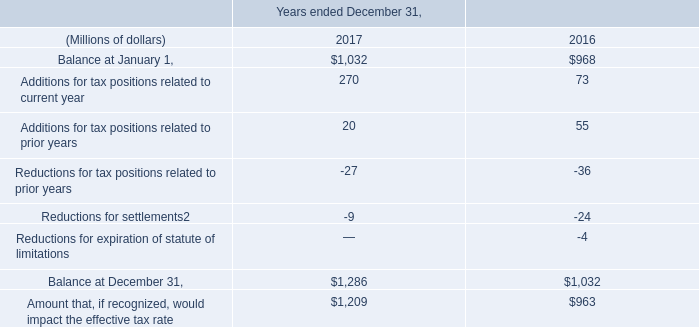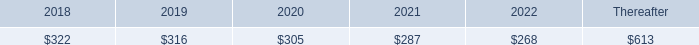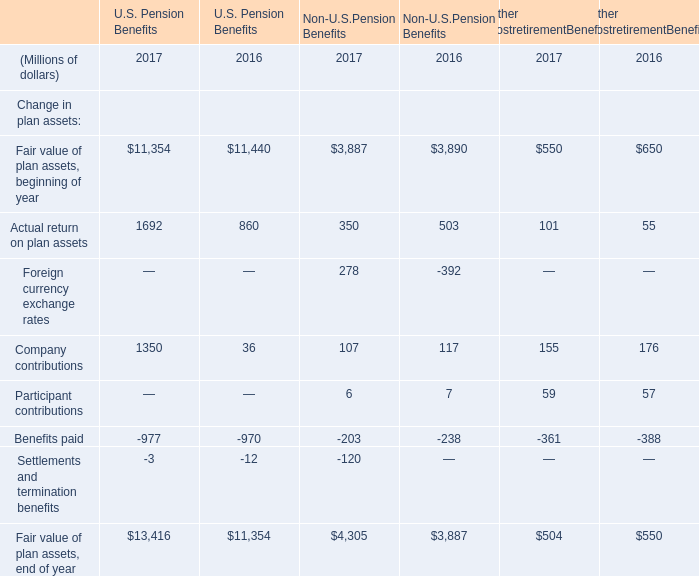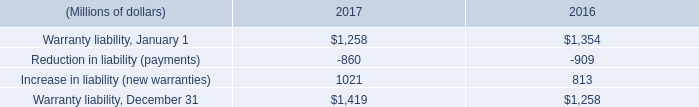what is the percentage change net provision for interest and penalties from 2016 to 2017? 
Computations: ((38 - 34) / 34)
Answer: 0.11765. 